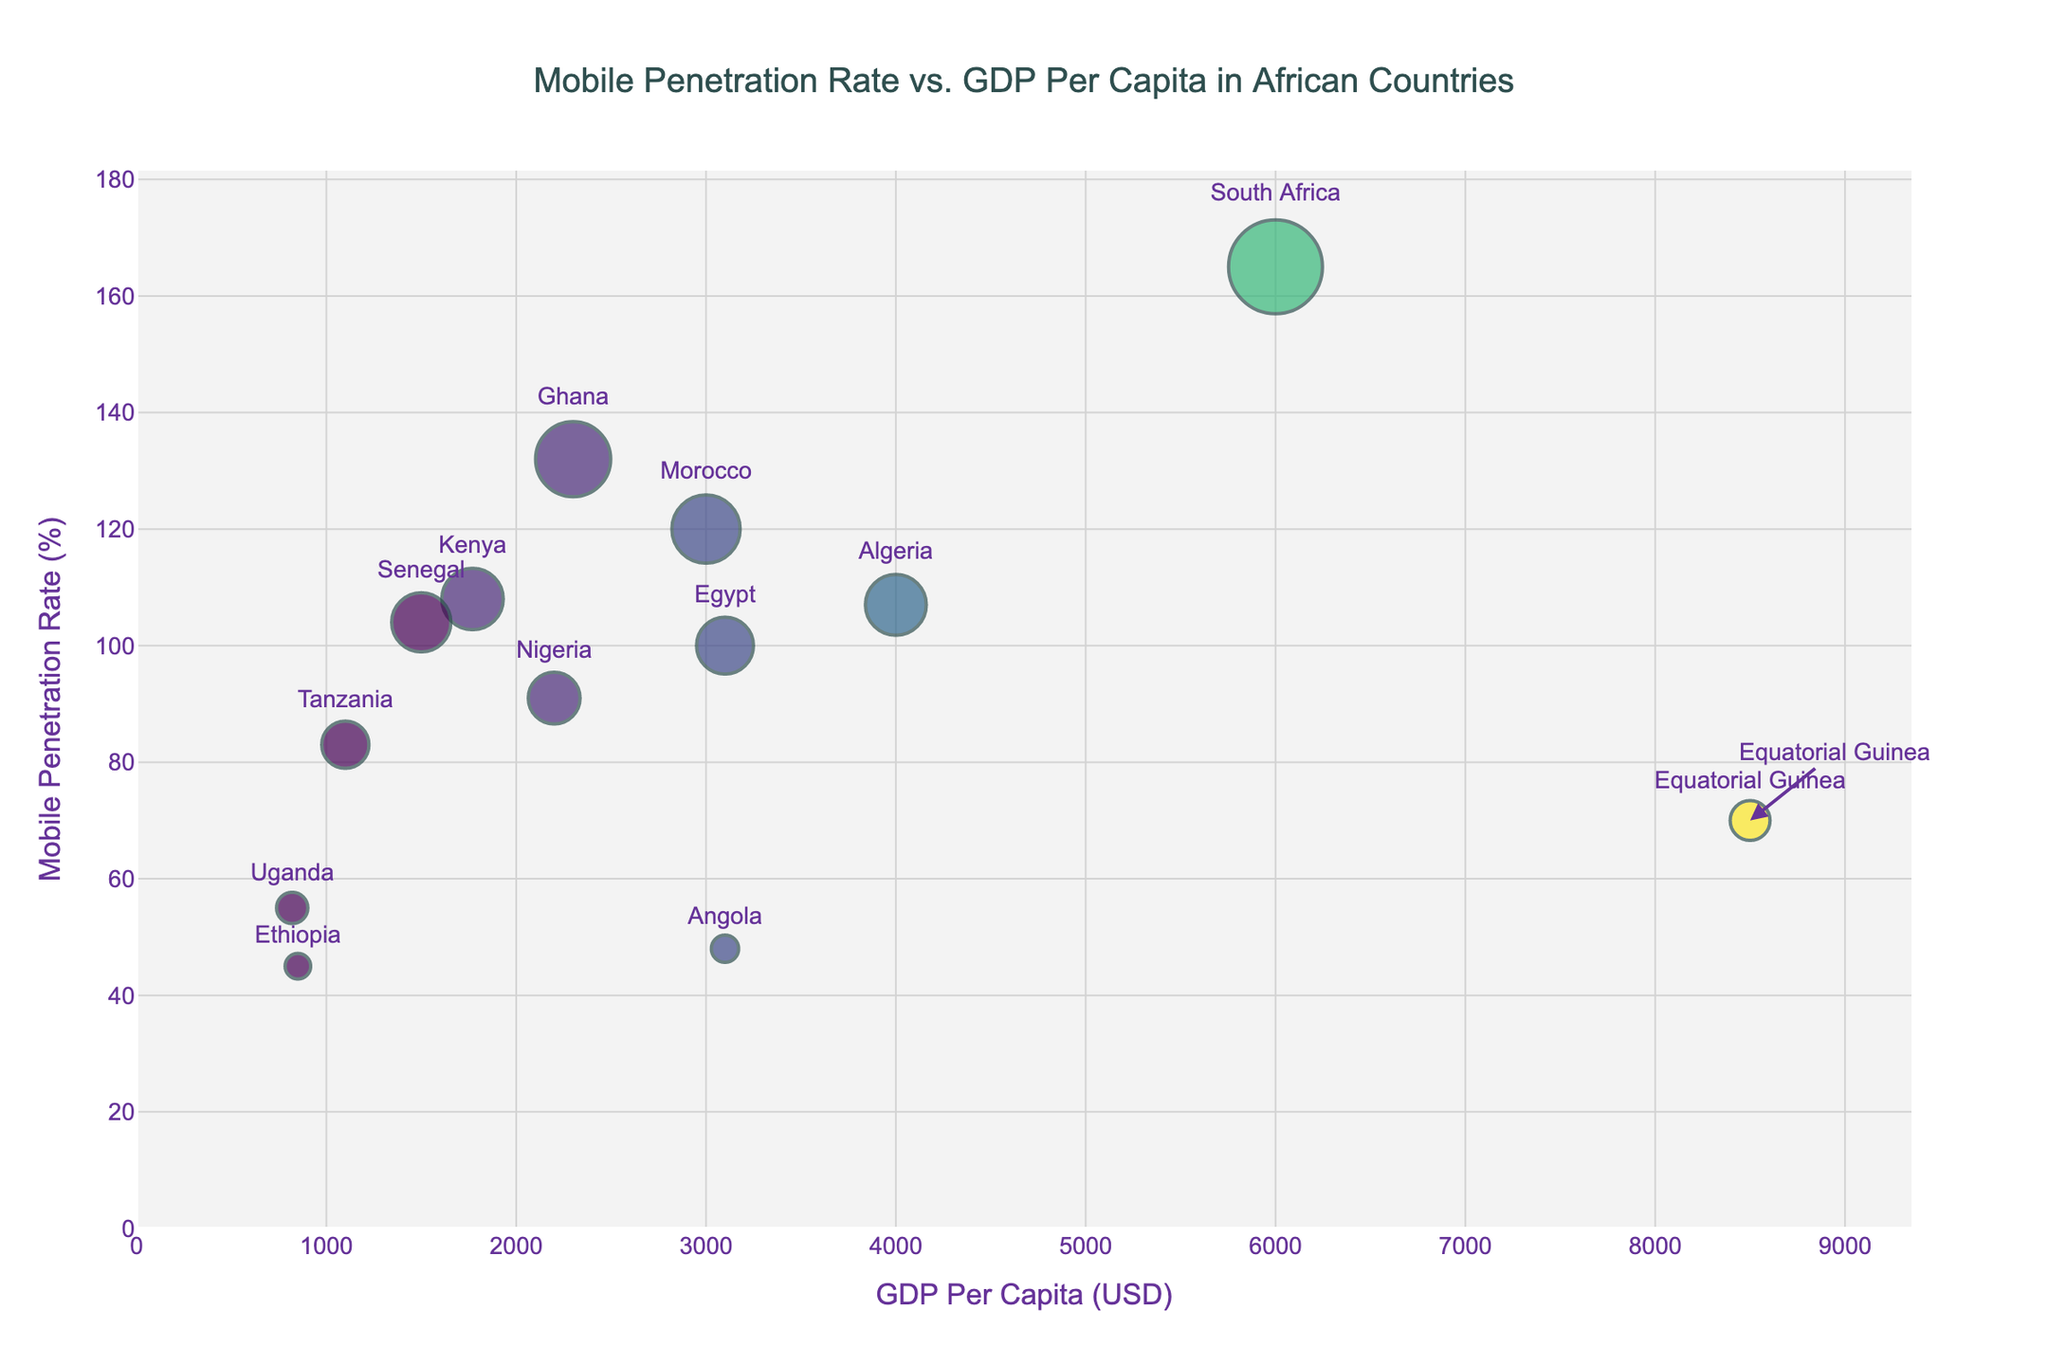What is the title of the scatter plot? The title is shown at the top of the scatter plot and describes the content and purpose of the graph.
Answer: Mobile Penetration Rate vs. GDP Per Capita in African Countries Which country has the highest mobile penetration rate? To determine this, look for the maximum value on the y-axis and identify the labeled data point.
Answer: South Africa What is the mobile penetration rate for Equatorial Guinea? Locate the data point for Equatorial Guinea and read the corresponding value on the y-axis.
Answer: 70% Which country has the lowest GDP per capita? Find the data point located closest to the origin on the x-axis and read the corresponding country label.
Answer: Uganda How does the mobile penetration rate of Equatorial Guinea compare to that of Kenya? Locate the data points for Equatorial Guinea and Kenya, then compare their positions on the y-axis to determine which is higher.
Answer: Kenya's rate is higher at 108% What is the average GDP per capita of Ghana and Senegal? Sum the GDP per capita values of Ghana and Senegal, then divide by 2 to find the average.
Answer: (2300 + 1500) / 2 = 1900 USD Which country has a GDP per capita of about 3000 USD and what is its mobile penetration rate? Find the data point close to a GDP per capita of 3000 USD and read both the country label and the corresponding mobile penetration rate on the y-axis.
Answer: Morocco, 120% How many countries have a mobile penetration rate greater than 100%? Count the number of data points that are above 100% on the y-axis.
Answer: 5 (South Africa, Kenya, Morocco, Algeria, Ghana) What is the difference in GDP per capita between Nigeria and Ethiopia? Subtract the GDP per capita of Ethiopia from that of Nigeria.
Answer: 2200 - 850 = 1350 USD Does there appear to be a positive correlation between GDP per capita and mobile penetration rate? Observe the overall trend of the data points. If higher GDP per capita values generally align with higher mobile penetration rates, it indicates a positive correlation.
Answer: No, the relationship is not clearly positive 